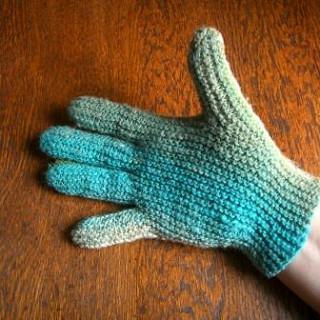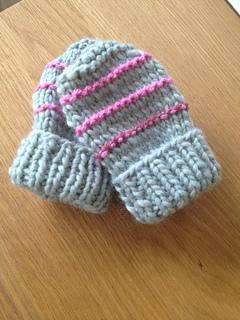The first image is the image on the left, the second image is the image on the right. Given the left and right images, does the statement "The left and right image contains a total of three gloves." hold true? Answer yes or no. Yes. The first image is the image on the left, the second image is the image on the right. Considering the images on both sides, is "One image shows a completed pair of 'mittens', and the other image shows a single completed item worn on the hand." valid? Answer yes or no. Yes. 